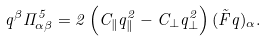Convert formula to latex. <formula><loc_0><loc_0><loc_500><loc_500>q ^ { \beta } \Pi ^ { 5 } _ { \alpha \beta } = 2 \left ( C _ { \| } q _ { \| } ^ { 2 } - C _ { \bot } q _ { \bot } ^ { 2 } \right ) ( \tilde { F } q ) _ { \alpha } .</formula> 